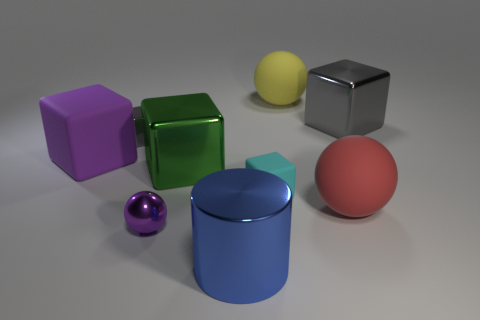Subtract 2 blocks. How many blocks are left? 3 Subtract all green blocks. How many blocks are left? 4 Subtract all purple matte cubes. How many cubes are left? 4 Subtract all cyan blocks. Subtract all gray spheres. How many blocks are left? 4 Add 1 matte objects. How many objects exist? 10 Subtract all cylinders. How many objects are left? 8 Add 4 big blocks. How many big blocks are left? 7 Add 4 large brown cubes. How many large brown cubes exist? 4 Subtract 1 cyan cubes. How many objects are left? 8 Subtract all big gray metallic spheres. Subtract all purple matte cubes. How many objects are left? 8 